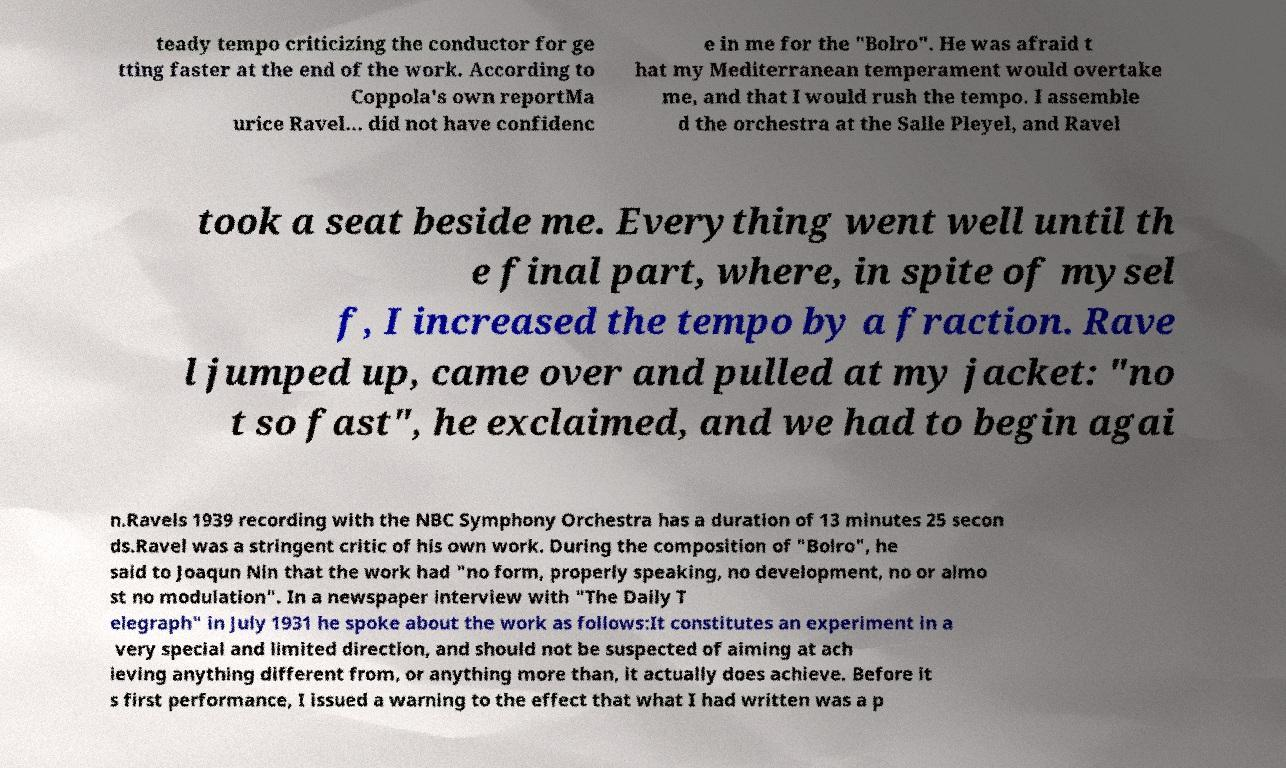Please identify and transcribe the text found in this image. teady tempo criticizing the conductor for ge tting faster at the end of the work. According to Coppola's own reportMa urice Ravel... did not have confidenc e in me for the "Bolro". He was afraid t hat my Mediterranean temperament would overtake me, and that I would rush the tempo. I assemble d the orchestra at the Salle Pleyel, and Ravel took a seat beside me. Everything went well until th e final part, where, in spite of mysel f, I increased the tempo by a fraction. Rave l jumped up, came over and pulled at my jacket: "no t so fast", he exclaimed, and we had to begin agai n.Ravels 1939 recording with the NBC Symphony Orchestra has a duration of 13 minutes 25 secon ds.Ravel was a stringent critic of his own work. During the composition of "Bolro", he said to Joaqun Nin that the work had "no form, properly speaking, no development, no or almo st no modulation". In a newspaper interview with "The Daily T elegraph" in July 1931 he spoke about the work as follows:It constitutes an experiment in a very special and limited direction, and should not be suspected of aiming at ach ieving anything different from, or anything more than, it actually does achieve. Before it s first performance, I issued a warning to the effect that what I had written was a p 